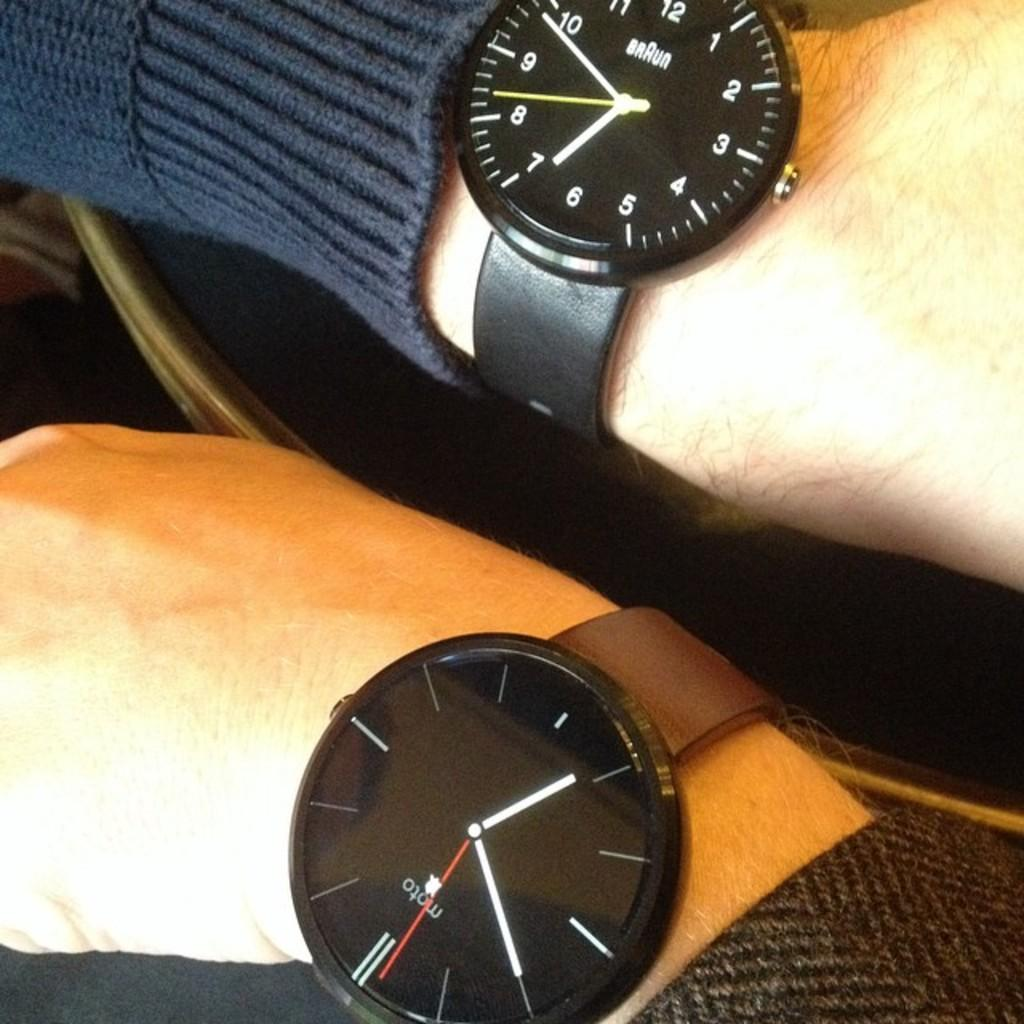How many people are in the image? There are two persons in the image. What part of their bodies is visible in the image? Each person has a wrist visible in the image. What objects are on the wrists of the persons? There are two watches in the image, one on each wrist. What type of metal is the kite made of in the image? There is no kite present in the image, so it is not possible to determine what type of metal it might be made of. 